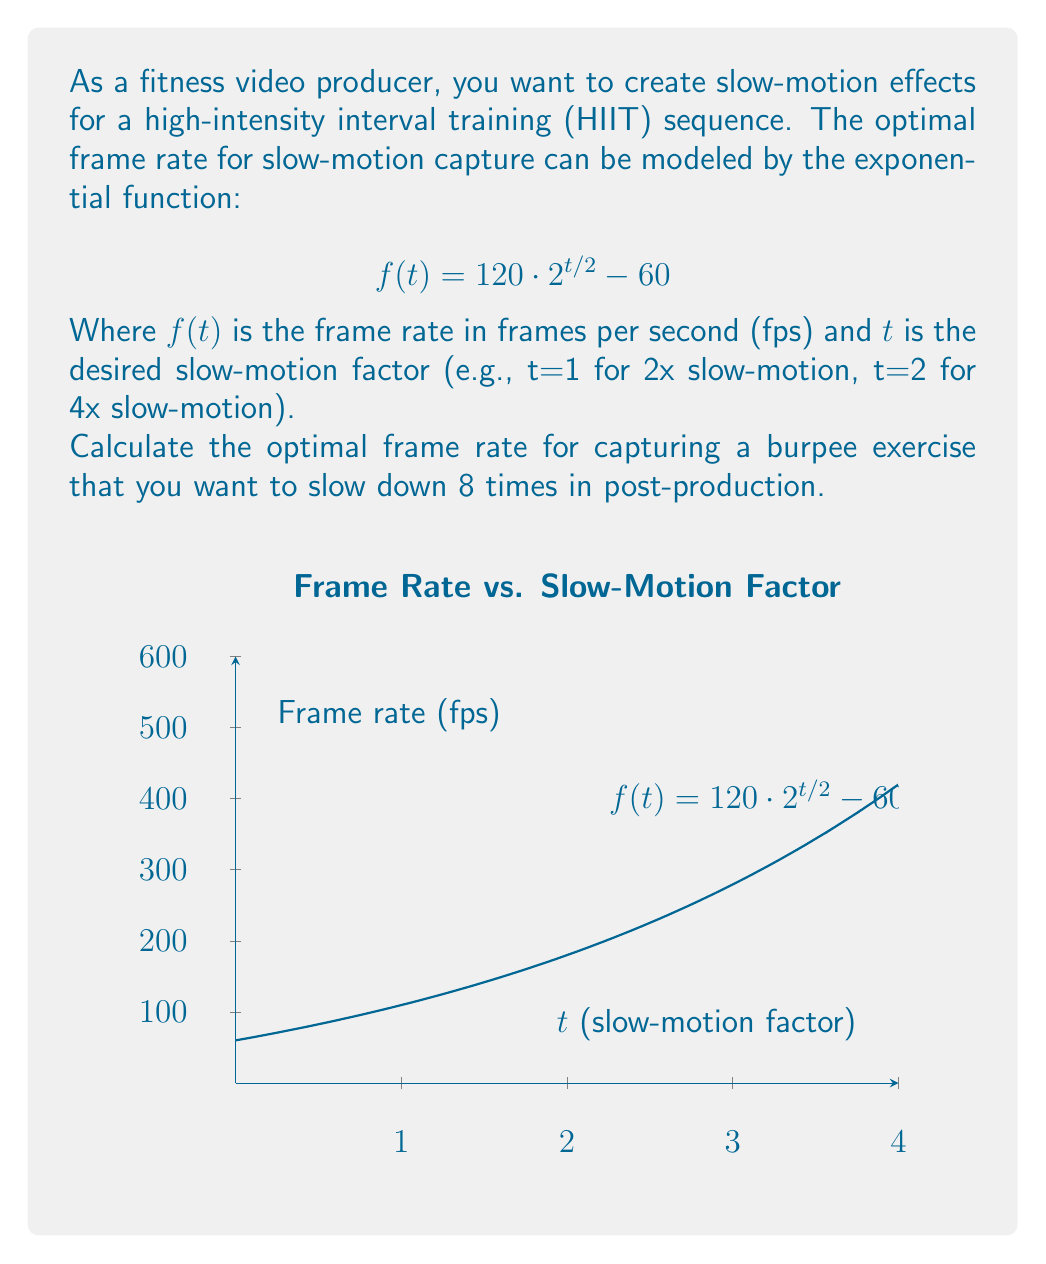Provide a solution to this math problem. Let's approach this step-by-step:

1) We're given the function: $f(t) = 120 \cdot 2^{t/2} - 60$

2) We want to slow down the footage 8 times, so we need to find $t$ where $2^t = 8$

3) Solving for $t$:
   $2^t = 8$
   $\log_2(2^t) = \log_2(8)$
   $t = 3$

4) Now we can plug $t = 3$ into our original function:

   $f(3) = 120 \cdot 2^{3/2} - 60$

5) Let's calculate this:
   $2^{3/2} = \sqrt{8} \approx 2.8284$
   
   $f(3) = 120 \cdot 2.8284 - 60$
   $f(3) = 339.408 - 60$
   $f(3) = 279.408$

6) Rounding to the nearest whole number (as frame rates are typically integer values):
   $f(3) \approx 279$ fps

Therefore, to achieve 8x slow-motion for the burpee exercise, you should capture the footage at approximately 279 frames per second.
Answer: 279 fps 